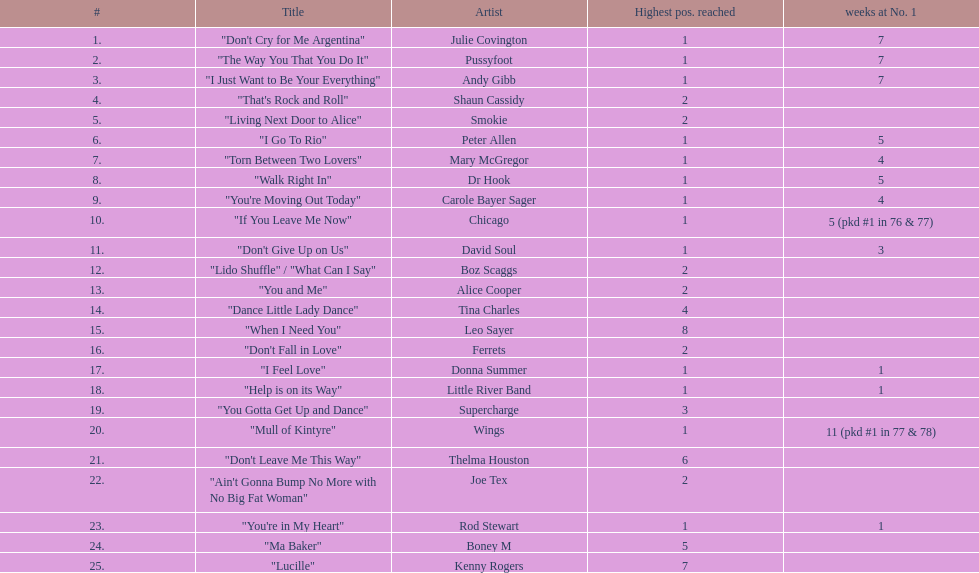Which tune maintained the number one rank for the longest duration? "Mull of Kintyre". 